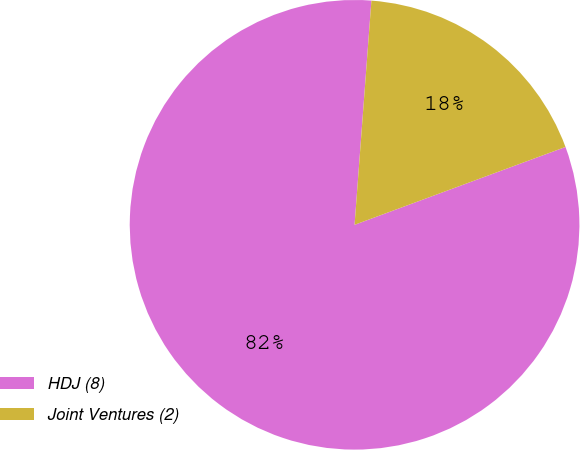Convert chart. <chart><loc_0><loc_0><loc_500><loc_500><pie_chart><fcel>HDJ (8)<fcel>Joint Ventures (2)<nl><fcel>81.82%<fcel>18.18%<nl></chart> 